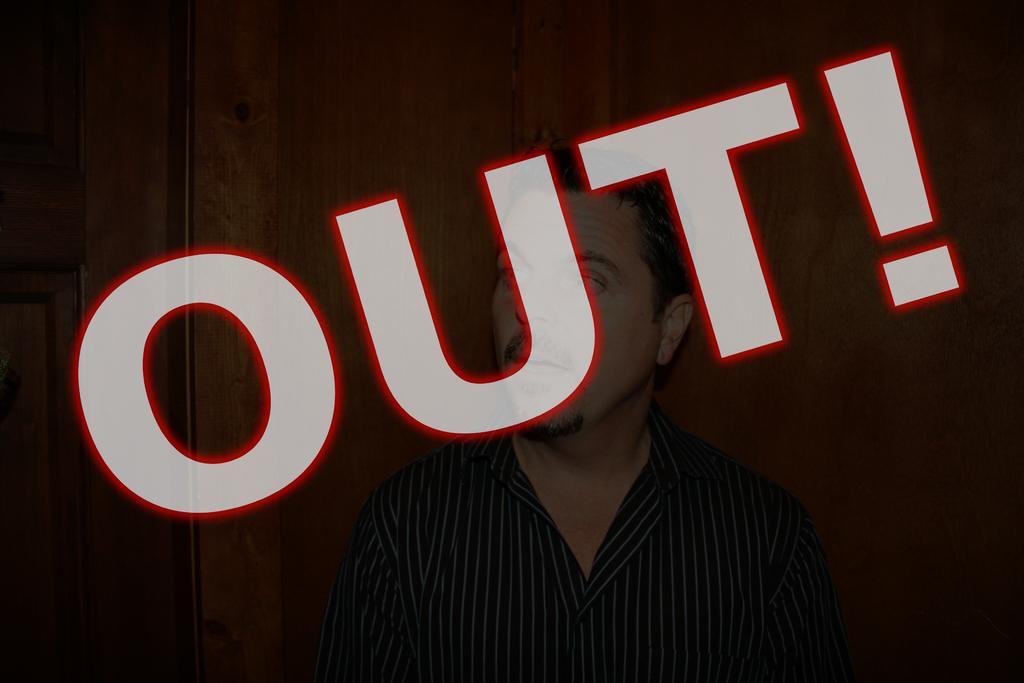Please provide a concise description of this image. In the center of the image a man and some text are there. In the background of the image wall is there. On the left side of the image door is there. 